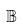<formula> <loc_0><loc_0><loc_500><loc_500>\mathbb { B }</formula> 